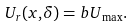<formula> <loc_0><loc_0><loc_500><loc_500>U _ { r } ( { x , } \delta ) = { b U } _ { \max } .</formula> 